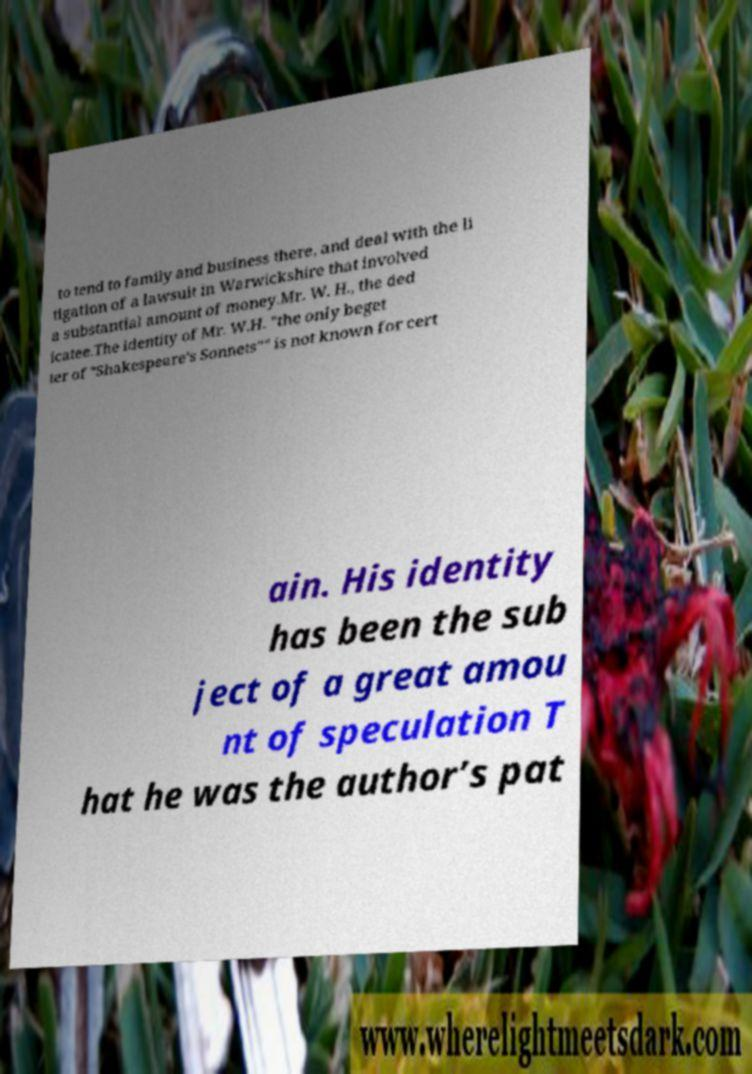Please identify and transcribe the text found in this image. to tend to family and business there, and deal with the li tigation of a lawsuit in Warwickshire that involved a substantial amount of money.Mr. W. H., the ded icatee.The identity of Mr. W.H. "the only beget ter of "Shakespeare's Sonnets"" is not known for cert ain. His identity has been the sub ject of a great amou nt of speculation T hat he was the author’s pat 